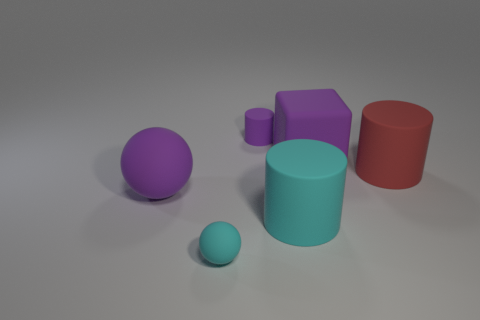There is a tiny rubber thing behind the big cyan rubber cylinder; does it have the same color as the large object behind the red matte cylinder?
Offer a terse response. Yes. There is a tiny cylinder on the left side of the big matte block; is its color the same as the cube?
Ensure brevity in your answer.  Yes. The red object that is the same shape as the small purple thing is what size?
Your response must be concise. Large. Is the small rubber cylinder the same color as the large block?
Give a very brief answer. Yes. There is another big object that is the same shape as the big cyan thing; what color is it?
Your response must be concise. Red. Does the large cyan rubber object have the same shape as the big matte object on the right side of the large matte cube?
Your answer should be compact. Yes. Does the large block have the same color as the ball behind the cyan rubber sphere?
Provide a short and direct response. Yes. Are there any other things that are the same shape as the small purple object?
Offer a very short reply. Yes. How many things have the same color as the tiny sphere?
Provide a succinct answer. 1. What number of big red objects are the same shape as the large cyan object?
Your answer should be compact. 1. 